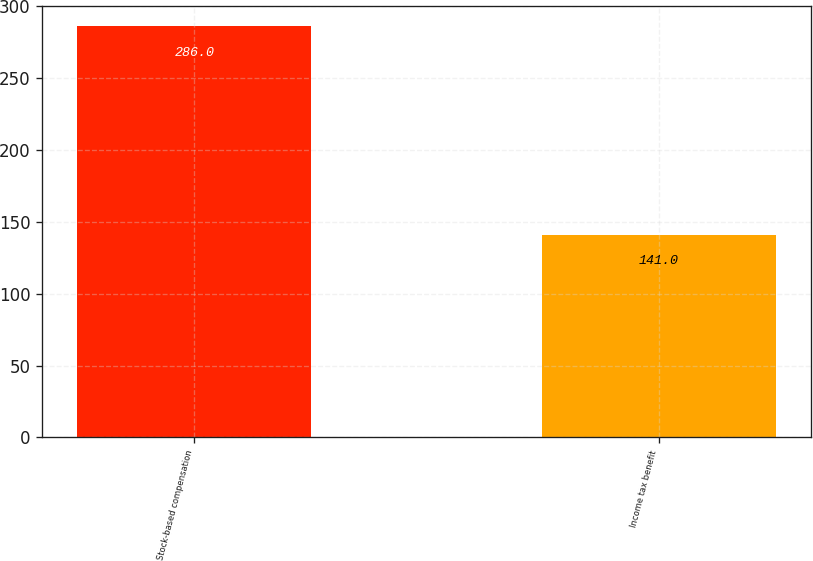Convert chart to OTSL. <chart><loc_0><loc_0><loc_500><loc_500><bar_chart><fcel>Stock-based compensation<fcel>Income tax benefit<nl><fcel>286<fcel>141<nl></chart> 